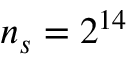<formula> <loc_0><loc_0><loc_500><loc_500>n _ { s } = 2 ^ { 1 4 }</formula> 